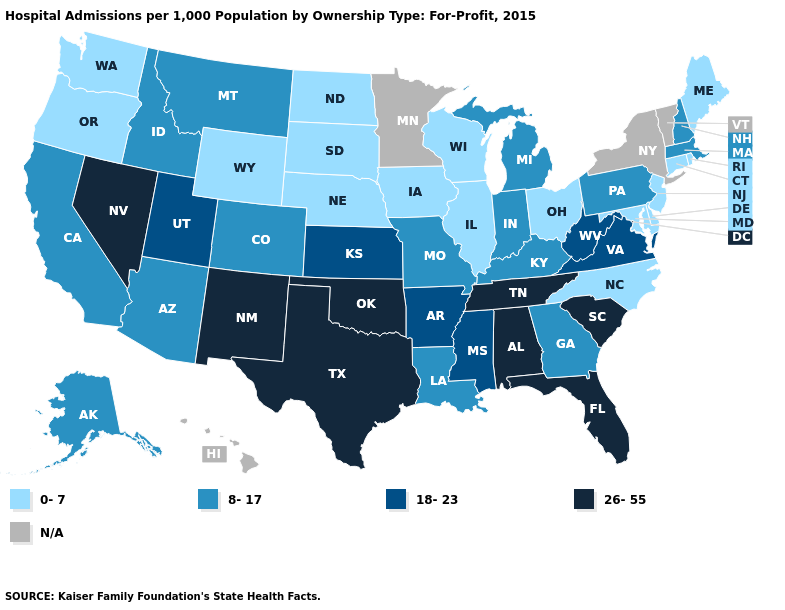Name the states that have a value in the range N/A?
Be succinct. Hawaii, Minnesota, New York, Vermont. Does the first symbol in the legend represent the smallest category?
Short answer required. Yes. Name the states that have a value in the range 18-23?
Write a very short answer. Arkansas, Kansas, Mississippi, Utah, Virginia, West Virginia. Name the states that have a value in the range 26-55?
Keep it brief. Alabama, Florida, Nevada, New Mexico, Oklahoma, South Carolina, Tennessee, Texas. Name the states that have a value in the range 26-55?
Keep it brief. Alabama, Florida, Nevada, New Mexico, Oklahoma, South Carolina, Tennessee, Texas. What is the value of New York?
Answer briefly. N/A. Name the states that have a value in the range N/A?
Concise answer only. Hawaii, Minnesota, New York, Vermont. What is the highest value in states that border Washington?
Answer briefly. 8-17. What is the value of Connecticut?
Give a very brief answer. 0-7. What is the lowest value in states that border Pennsylvania?
Write a very short answer. 0-7. Which states have the lowest value in the MidWest?
Keep it brief. Illinois, Iowa, Nebraska, North Dakota, Ohio, South Dakota, Wisconsin. Name the states that have a value in the range 0-7?
Short answer required. Connecticut, Delaware, Illinois, Iowa, Maine, Maryland, Nebraska, New Jersey, North Carolina, North Dakota, Ohio, Oregon, Rhode Island, South Dakota, Washington, Wisconsin, Wyoming. Is the legend a continuous bar?
Keep it brief. No. What is the value of Nebraska?
Concise answer only. 0-7. 